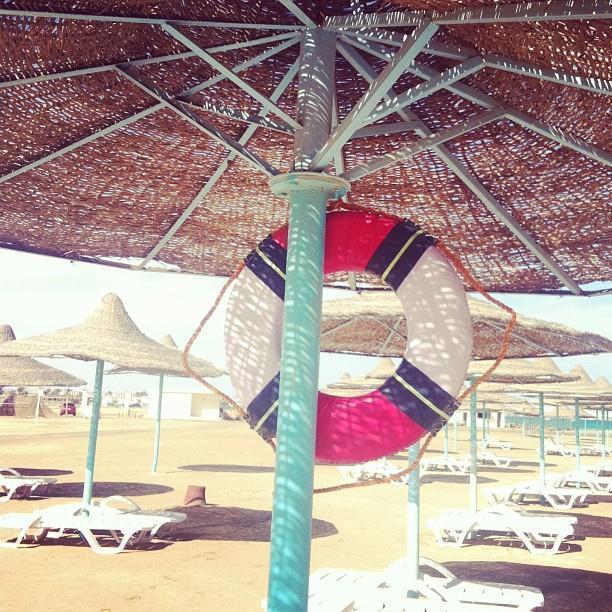The shade held by the teal umbrella pole was crafted in which manner?
Make your selection from the four choices given to correctly answer the question.
Options: Carving, sewing machine, weaving, axe. Weaving. 